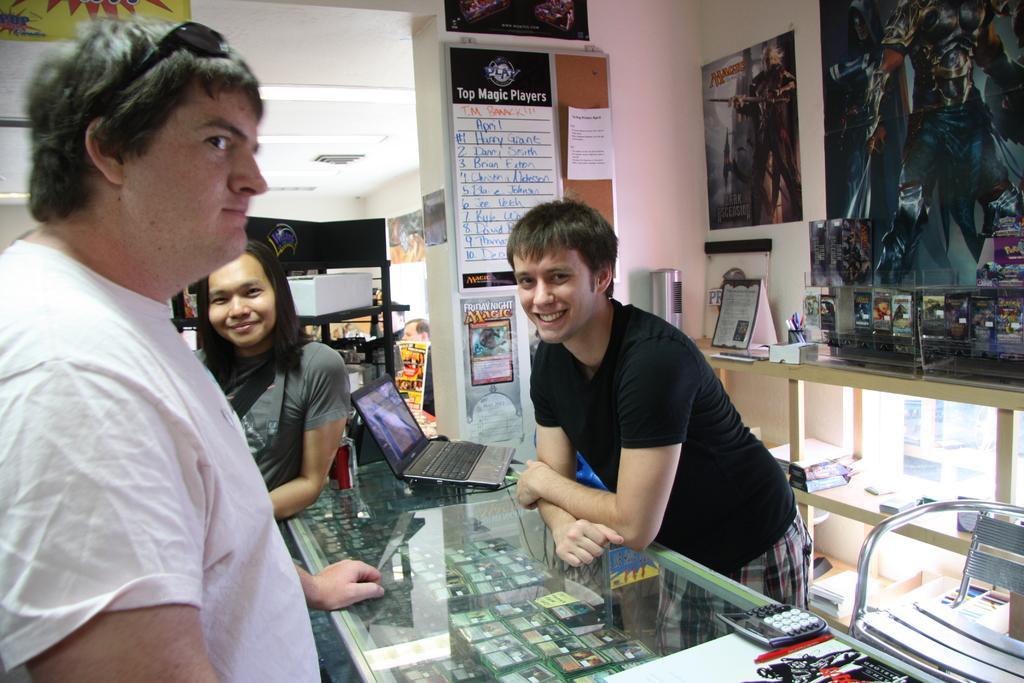Could you give a brief overview of what you see in this image? In the picture I can see some people are standing, in between them we can see a glass table, behind there are some posters attached to the wall. 